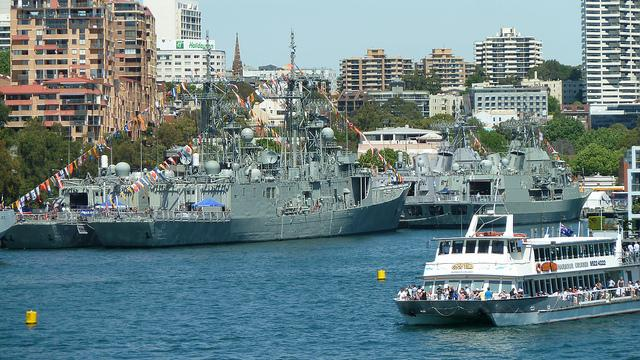What vehicle used for this water transportation?

Choices:
A) yacht
B) canoe
C) cargo ship
D) raft boat cargo ship 